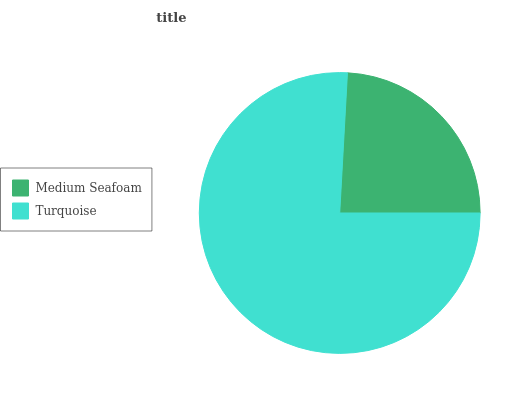Is Medium Seafoam the minimum?
Answer yes or no. Yes. Is Turquoise the maximum?
Answer yes or no. Yes. Is Turquoise the minimum?
Answer yes or no. No. Is Turquoise greater than Medium Seafoam?
Answer yes or no. Yes. Is Medium Seafoam less than Turquoise?
Answer yes or no. Yes. Is Medium Seafoam greater than Turquoise?
Answer yes or no. No. Is Turquoise less than Medium Seafoam?
Answer yes or no. No. Is Turquoise the high median?
Answer yes or no. Yes. Is Medium Seafoam the low median?
Answer yes or no. Yes. Is Medium Seafoam the high median?
Answer yes or no. No. Is Turquoise the low median?
Answer yes or no. No. 